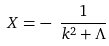<formula> <loc_0><loc_0><loc_500><loc_500>X = - \ \frac { 1 } { k ^ { 2 } + \Lambda }</formula> 